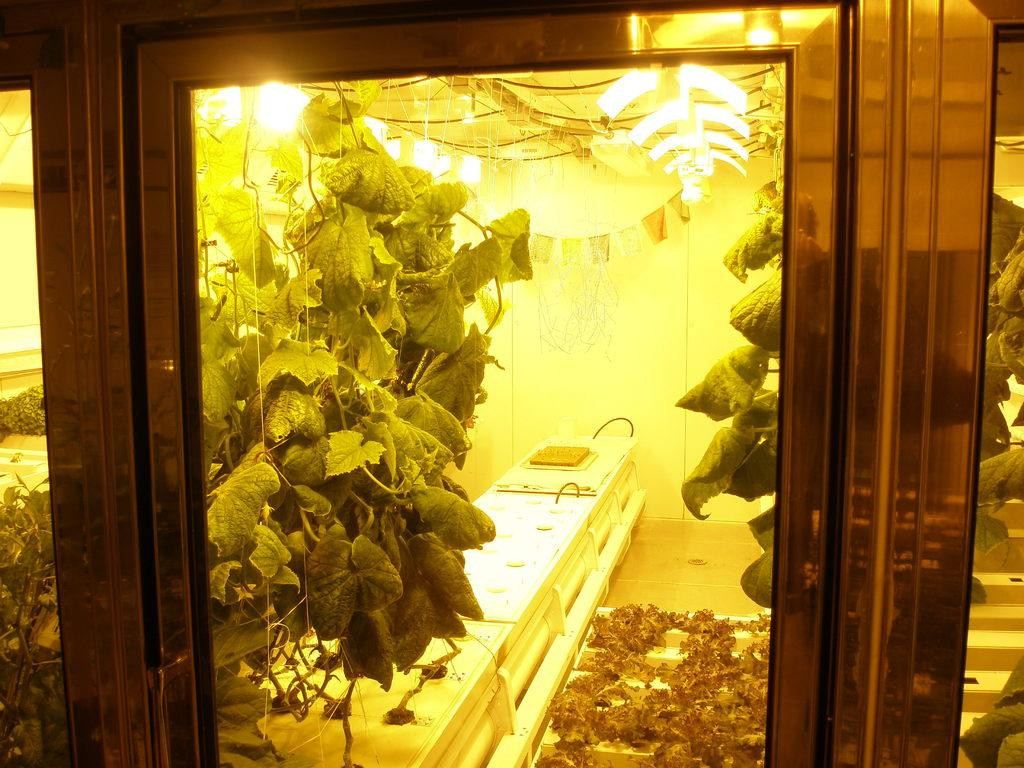What type of door is visible in the image? There is a glass door in the image. What can be seen through the glass door? Leaves are visible behind the glass door. What is behind the leaves in the image? There is a wall behind the leaves. What is present at the top of the image? Lights are present on the top of the image. Can you see a duck swimming in the image? There is no duck present in the image. Is there a plough being used in the image? There is no plough present in the image. 